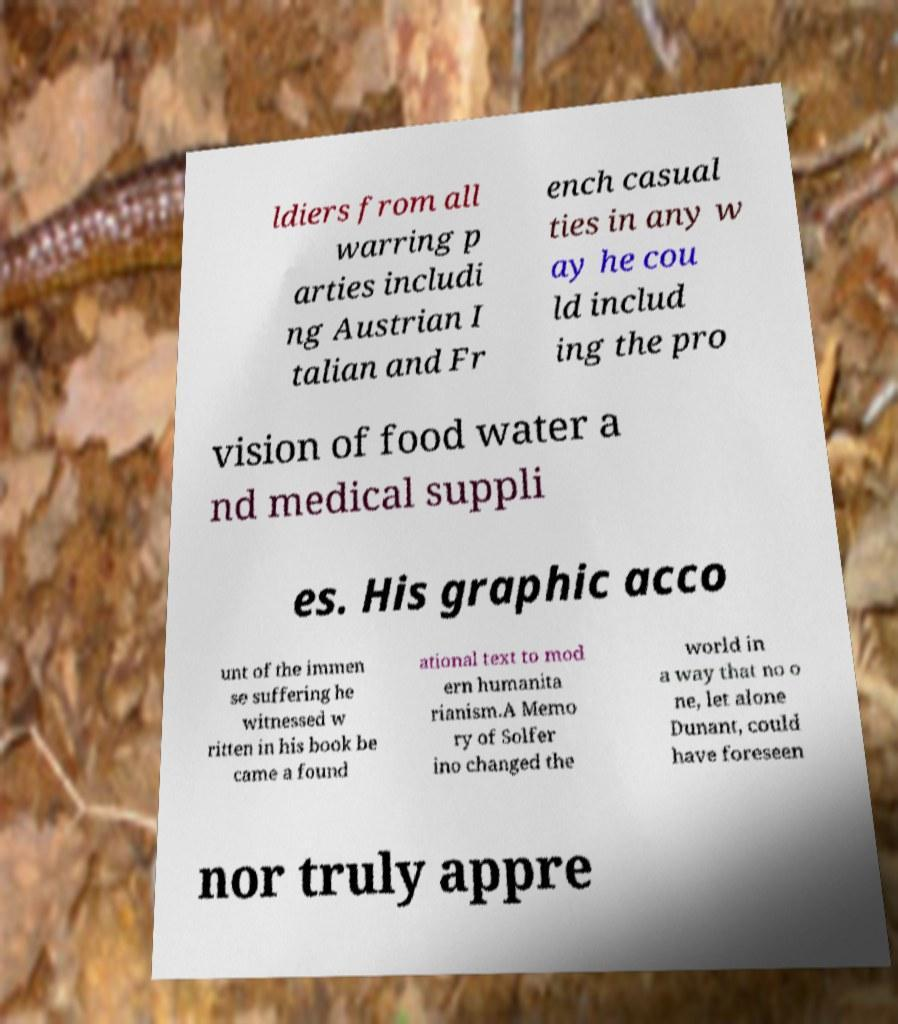I need the written content from this picture converted into text. Can you do that? ldiers from all warring p arties includi ng Austrian I talian and Fr ench casual ties in any w ay he cou ld includ ing the pro vision of food water a nd medical suppli es. His graphic acco unt of the immen se suffering he witnessed w ritten in his book be came a found ational text to mod ern humanita rianism.A Memo ry of Solfer ino changed the world in a way that no o ne, let alone Dunant, could have foreseen nor truly appre 